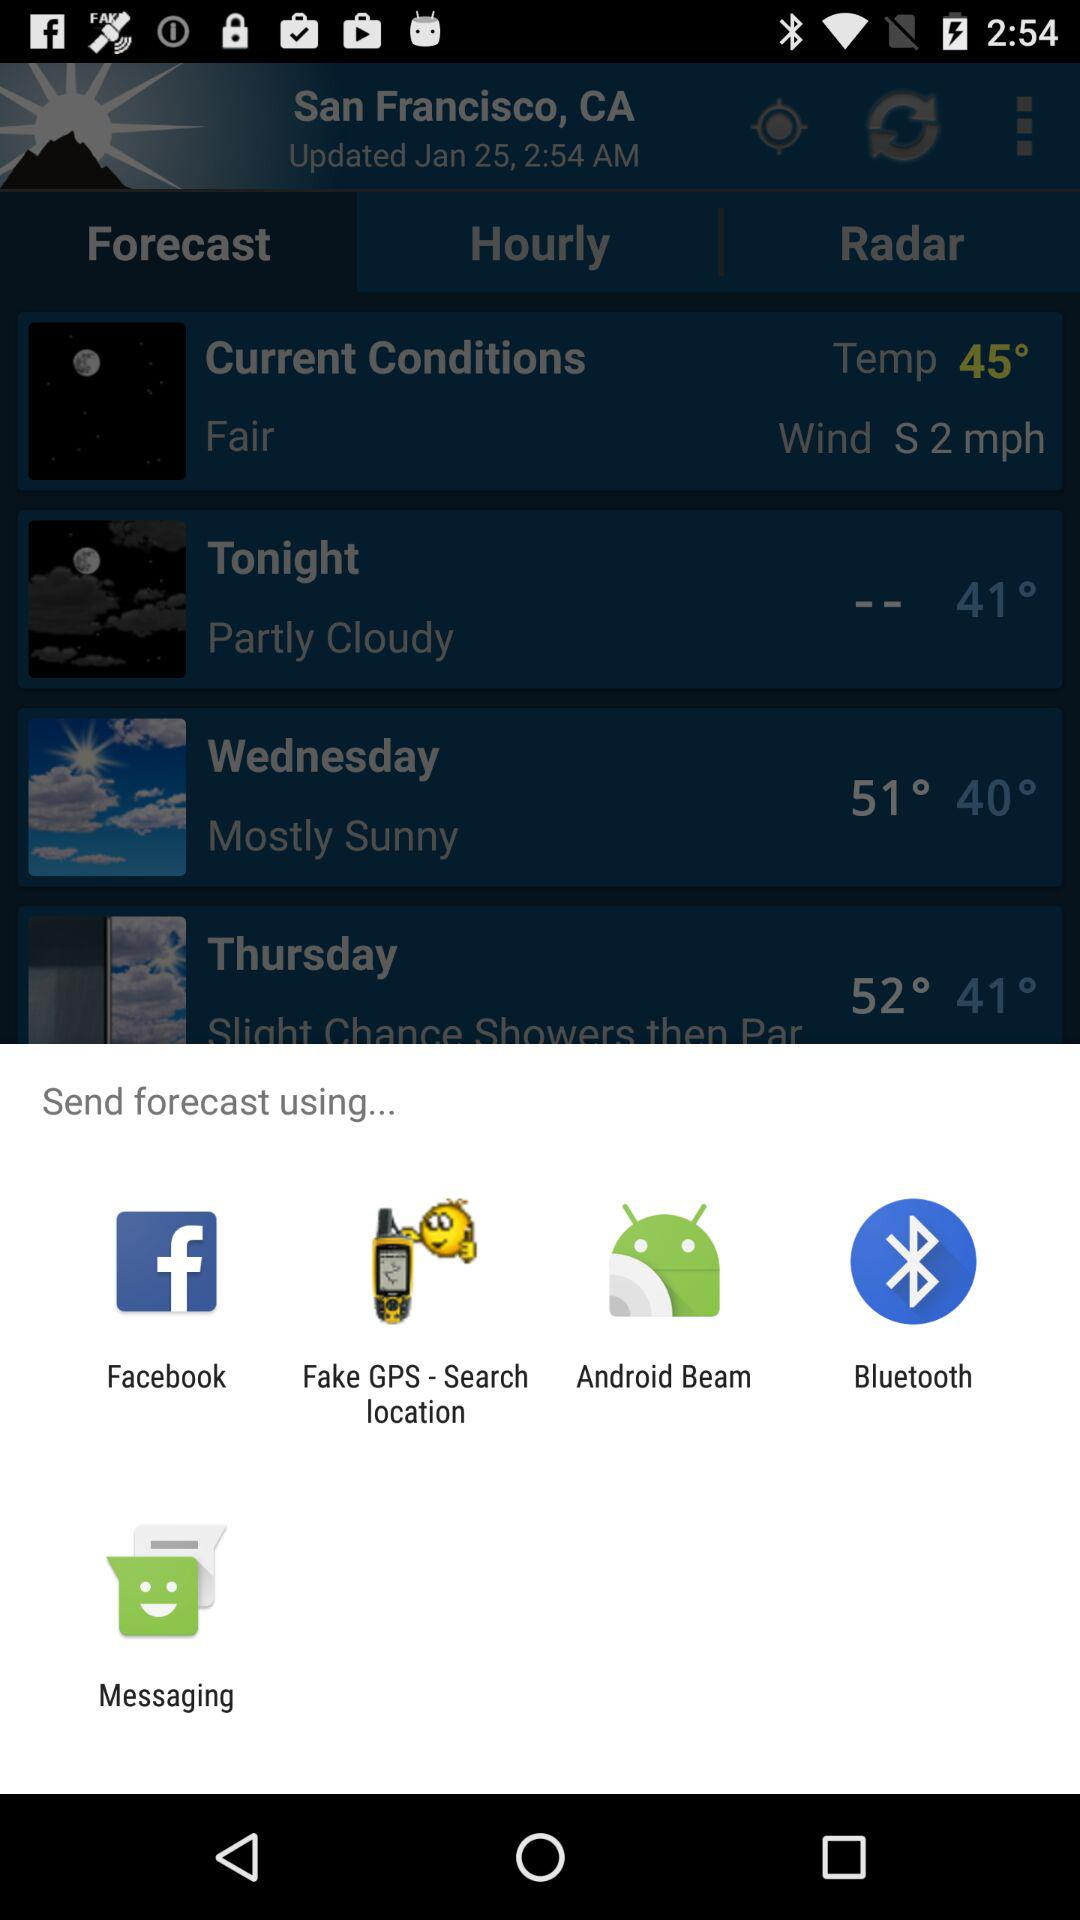What is the temperature tonight? The temperature is 41 degrees. 